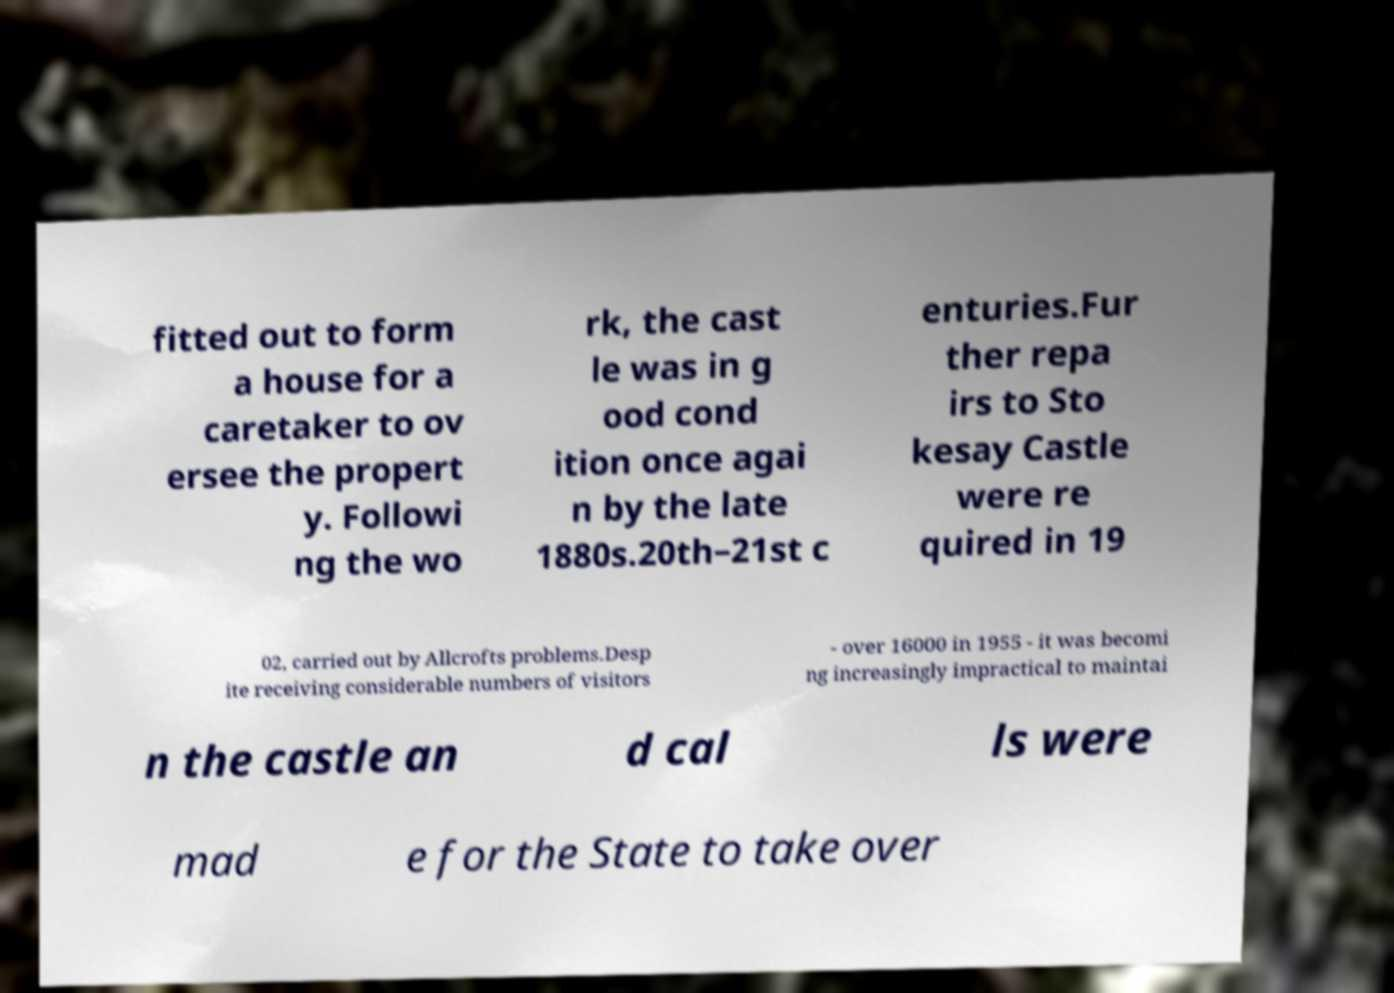Could you extract and type out the text from this image? fitted out to form a house for a caretaker to ov ersee the propert y. Followi ng the wo rk, the cast le was in g ood cond ition once agai n by the late 1880s.20th–21st c enturies.Fur ther repa irs to Sto kesay Castle were re quired in 19 02, carried out by Allcrofts problems.Desp ite receiving considerable numbers of visitors - over 16000 in 1955 - it was becomi ng increasingly impractical to maintai n the castle an d cal ls were mad e for the State to take over 